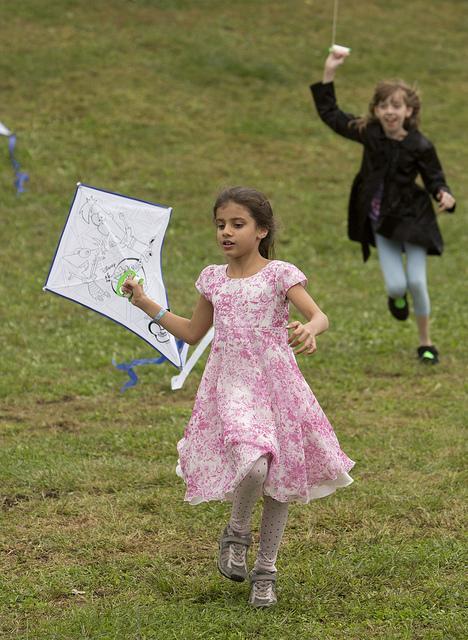What is the girl in pink wearing?
Choose the right answer and clarify with the format: 'Answer: answer
Rationale: rationale.'
Options: Smock, garbage bag, dress, lab coat. Answer: dress.
Rationale: A young girl is holding a kite. she is wearing a long pink and white piece of clothing. 